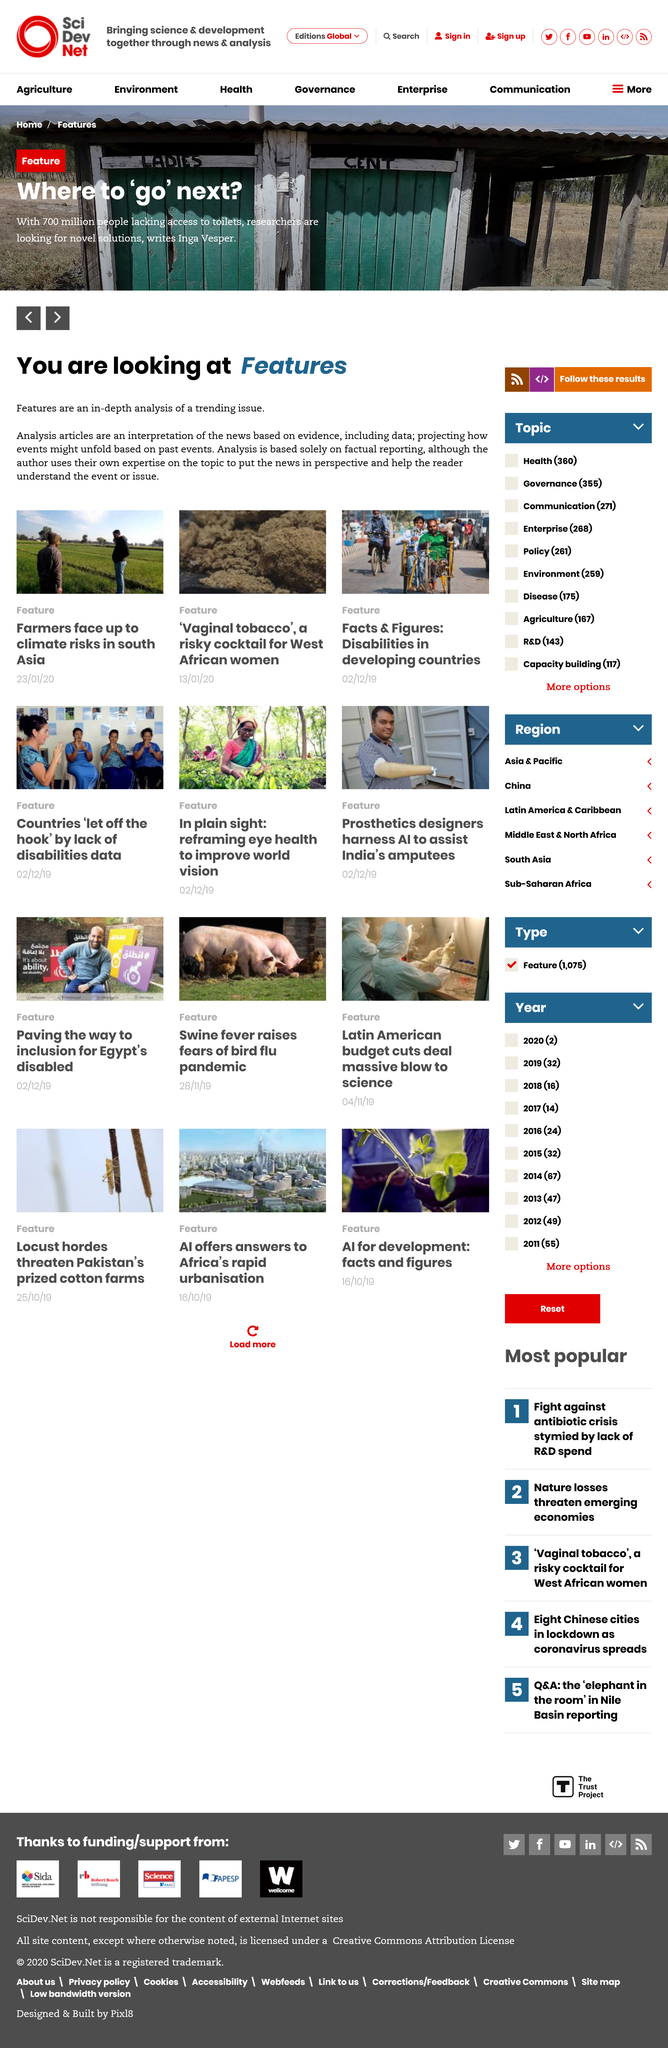Give some essential details in this illustration. Inga Vesper is the author of the article "Where to 'go' next?" as stated in the article itself. It is estimated that 700 million people lack access to toilets, according to reports. Yes, the "Where to 'go' next?" article is regarding access to toilets. 